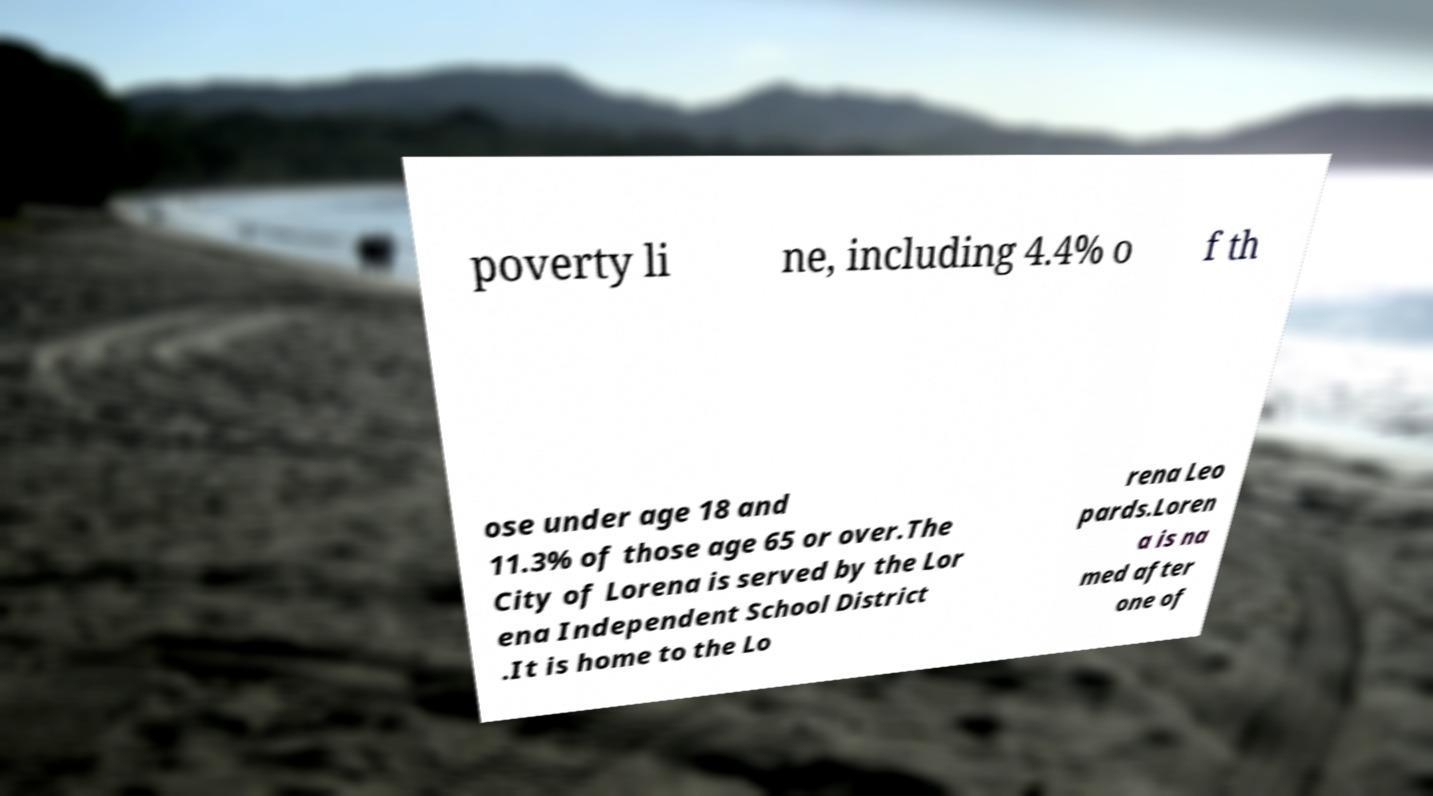Could you assist in decoding the text presented in this image and type it out clearly? poverty li ne, including 4.4% o f th ose under age 18 and 11.3% of those age 65 or over.The City of Lorena is served by the Lor ena Independent School District .It is home to the Lo rena Leo pards.Loren a is na med after one of 